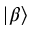Convert formula to latex. <formula><loc_0><loc_0><loc_500><loc_500>| \beta \rangle</formula> 